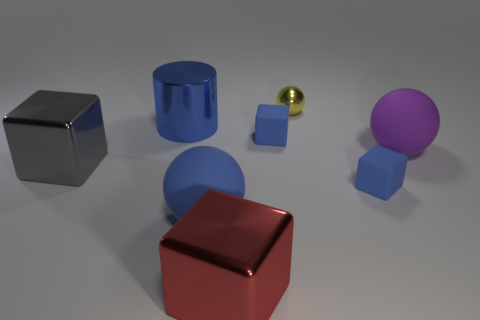Subtract all large gray metallic cubes. How many cubes are left? 3 Add 2 tiny matte cubes. How many objects exist? 10 Subtract all gray cylinders. How many blue cubes are left? 2 Subtract 3 cubes. How many cubes are left? 1 Subtract all cylinders. How many objects are left? 7 Add 6 gray things. How many gray things exist? 7 Subtract all blue spheres. How many spheres are left? 2 Subtract 0 green cylinders. How many objects are left? 8 Subtract all red balls. Subtract all green cylinders. How many balls are left? 3 Subtract all red metallic objects. Subtract all large blue shiny cylinders. How many objects are left? 6 